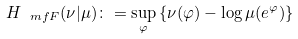<formula> <loc_0><loc_0><loc_500><loc_500>H _ { \ m f F } ( \nu | \mu ) \colon = \sup _ { \varphi } \left \{ \nu ( \varphi ) - \log \mu ( e ^ { \varphi } ) \right \}</formula> 